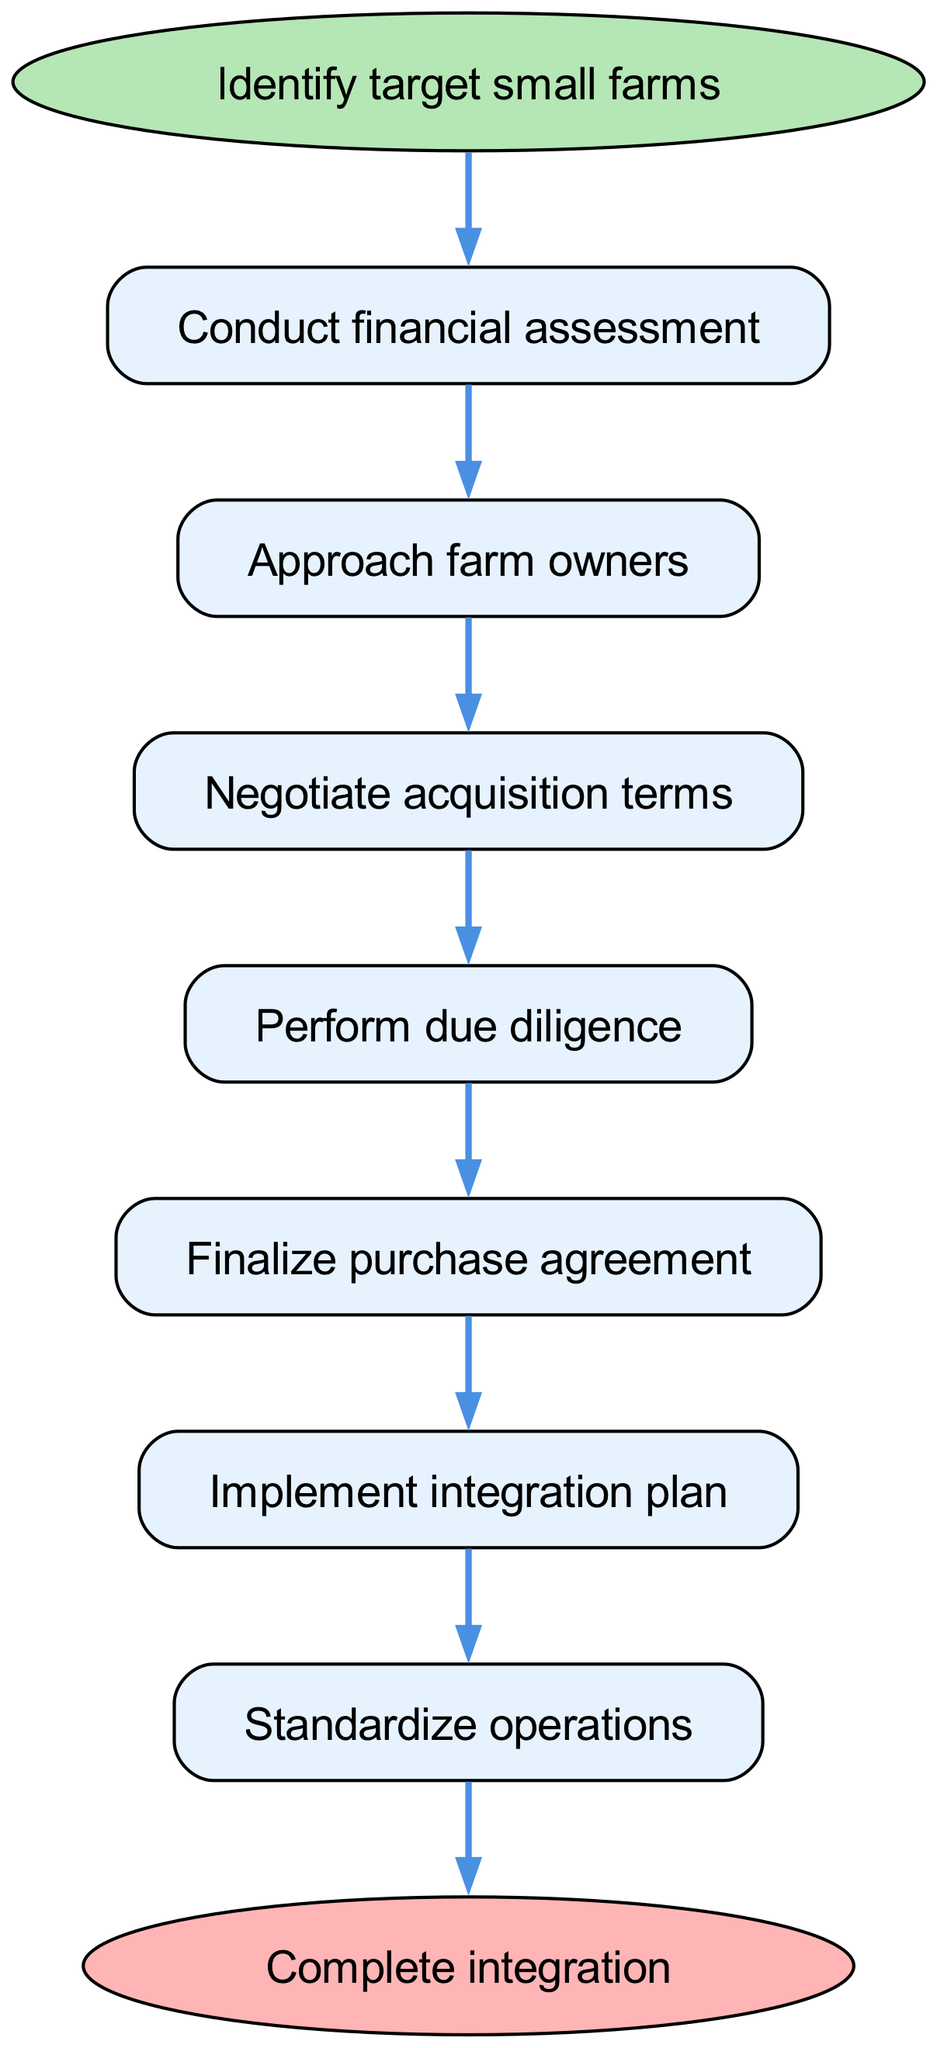What is the first step in the acquisition process? The diagram starts with the "Identify target small farms" node, which is the initial action in the sequence of steps for acquiring smaller farming operations.
Answer: Identify target small farms How many steps are there in the integration process? The diagram shows a total of 8 steps, including the start and end nodes, represented sequentially from identification to completion of integration.
Answer: 8 What follows after "Approach farm owners"? In the flow chart, the step following "Approach farm owners" is "Negotiate acquisition terms." It illustrates the next phase in the acquisition journey.
Answer: Negotiate acquisition terms What is the last step in the integration procedure? The final step depicted in the diagram is "Complete integration," denoting the end of the process after all prior steps have been executed.
Answer: Complete integration Which step comes before "Finalize purchase agreement"? The step that precedes "Finalize purchase agreement" in the flow chart is "Perform due diligence," indicating the necessary assessment made before formalizing the purchase.
Answer: Perform due diligence What are the total connections in the diagram? The diagram contains 7 connections, indicating the progression from one step to the next across the flow chart.
Answer: 7 What is the relationship between "Implement integration plan" and "Standardize operations"? In the flow chart, "Implement integration plan" directly precedes "Standardize operations," indicating that a successful implementation leads to the standardization of processes post-acquisition.
Answer: Implement integration plan leads to Standardize operations How many nodes are required for the process from start to end? The process requires 8 nodes which include the start and finish points as well as the six steps in between, depicting a clear path from initiation to completion.
Answer: 8 nodes What step follows "Perform due diligence"? The step that follows "Perform due diligence" is "Finalize purchase agreement," which signifies the transition from assessment to formal acquisition agreement.
Answer: Finalize purchase agreement 